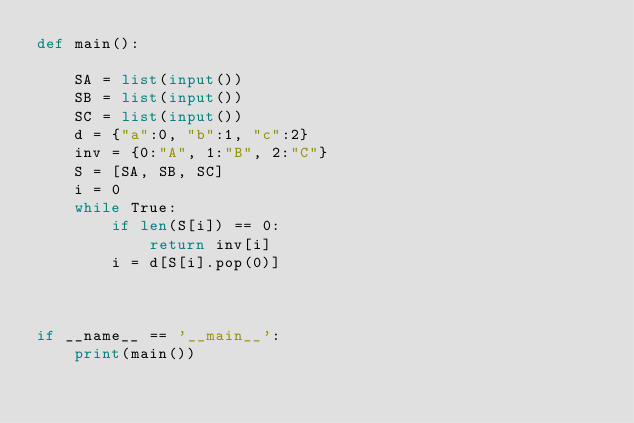<code> <loc_0><loc_0><loc_500><loc_500><_Python_>def main():

    SA = list(input())
    SB = list(input())
    SC = list(input())
    d = {"a":0, "b":1, "c":2}
    inv = {0:"A", 1:"B", 2:"C"}
    S = [SA, SB, SC]
    i = 0
    while True:
        if len(S[i]) == 0:
            return inv[i]
        i = d[S[i].pop(0)]



if __name__ == '__main__':
    print(main())</code> 